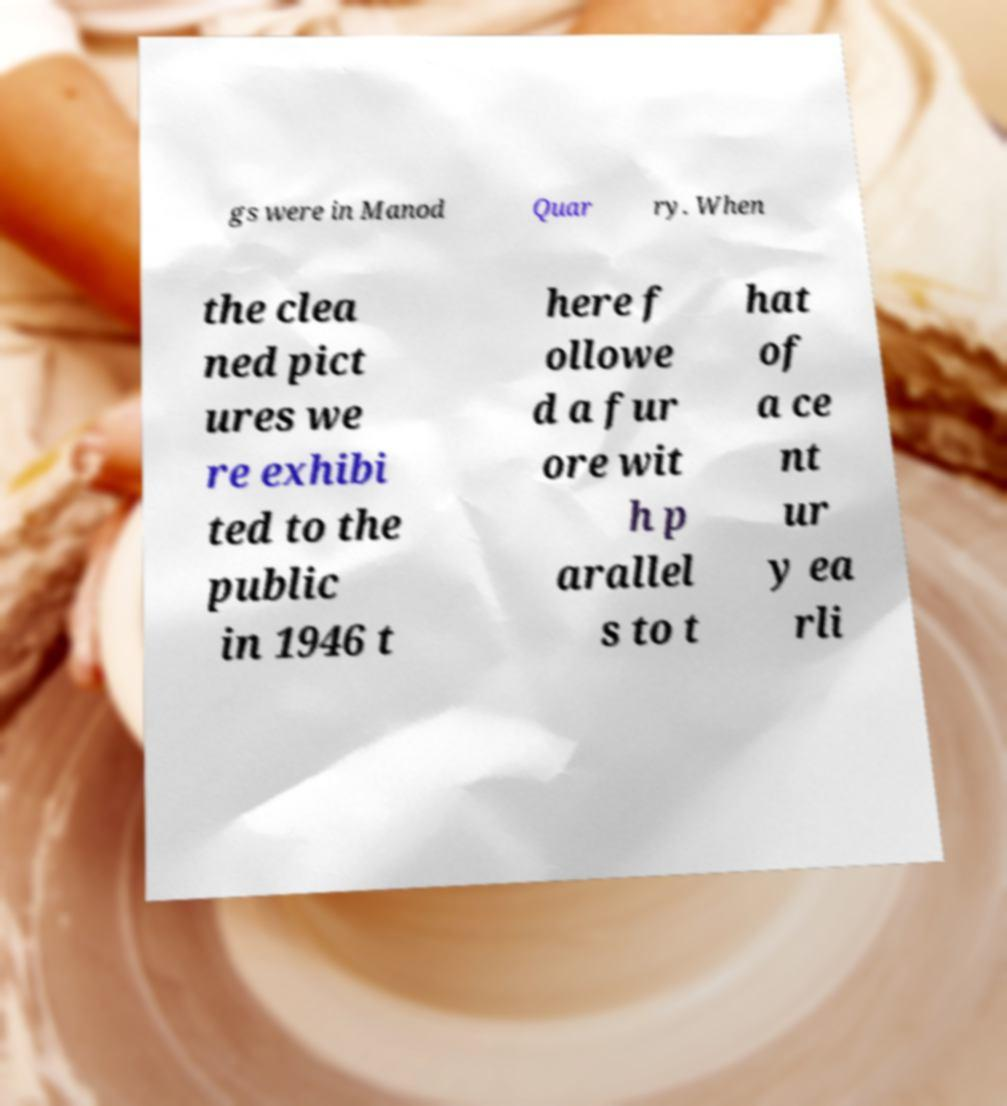I need the written content from this picture converted into text. Can you do that? gs were in Manod Quar ry. When the clea ned pict ures we re exhibi ted to the public in 1946 t here f ollowe d a fur ore wit h p arallel s to t hat of a ce nt ur y ea rli 